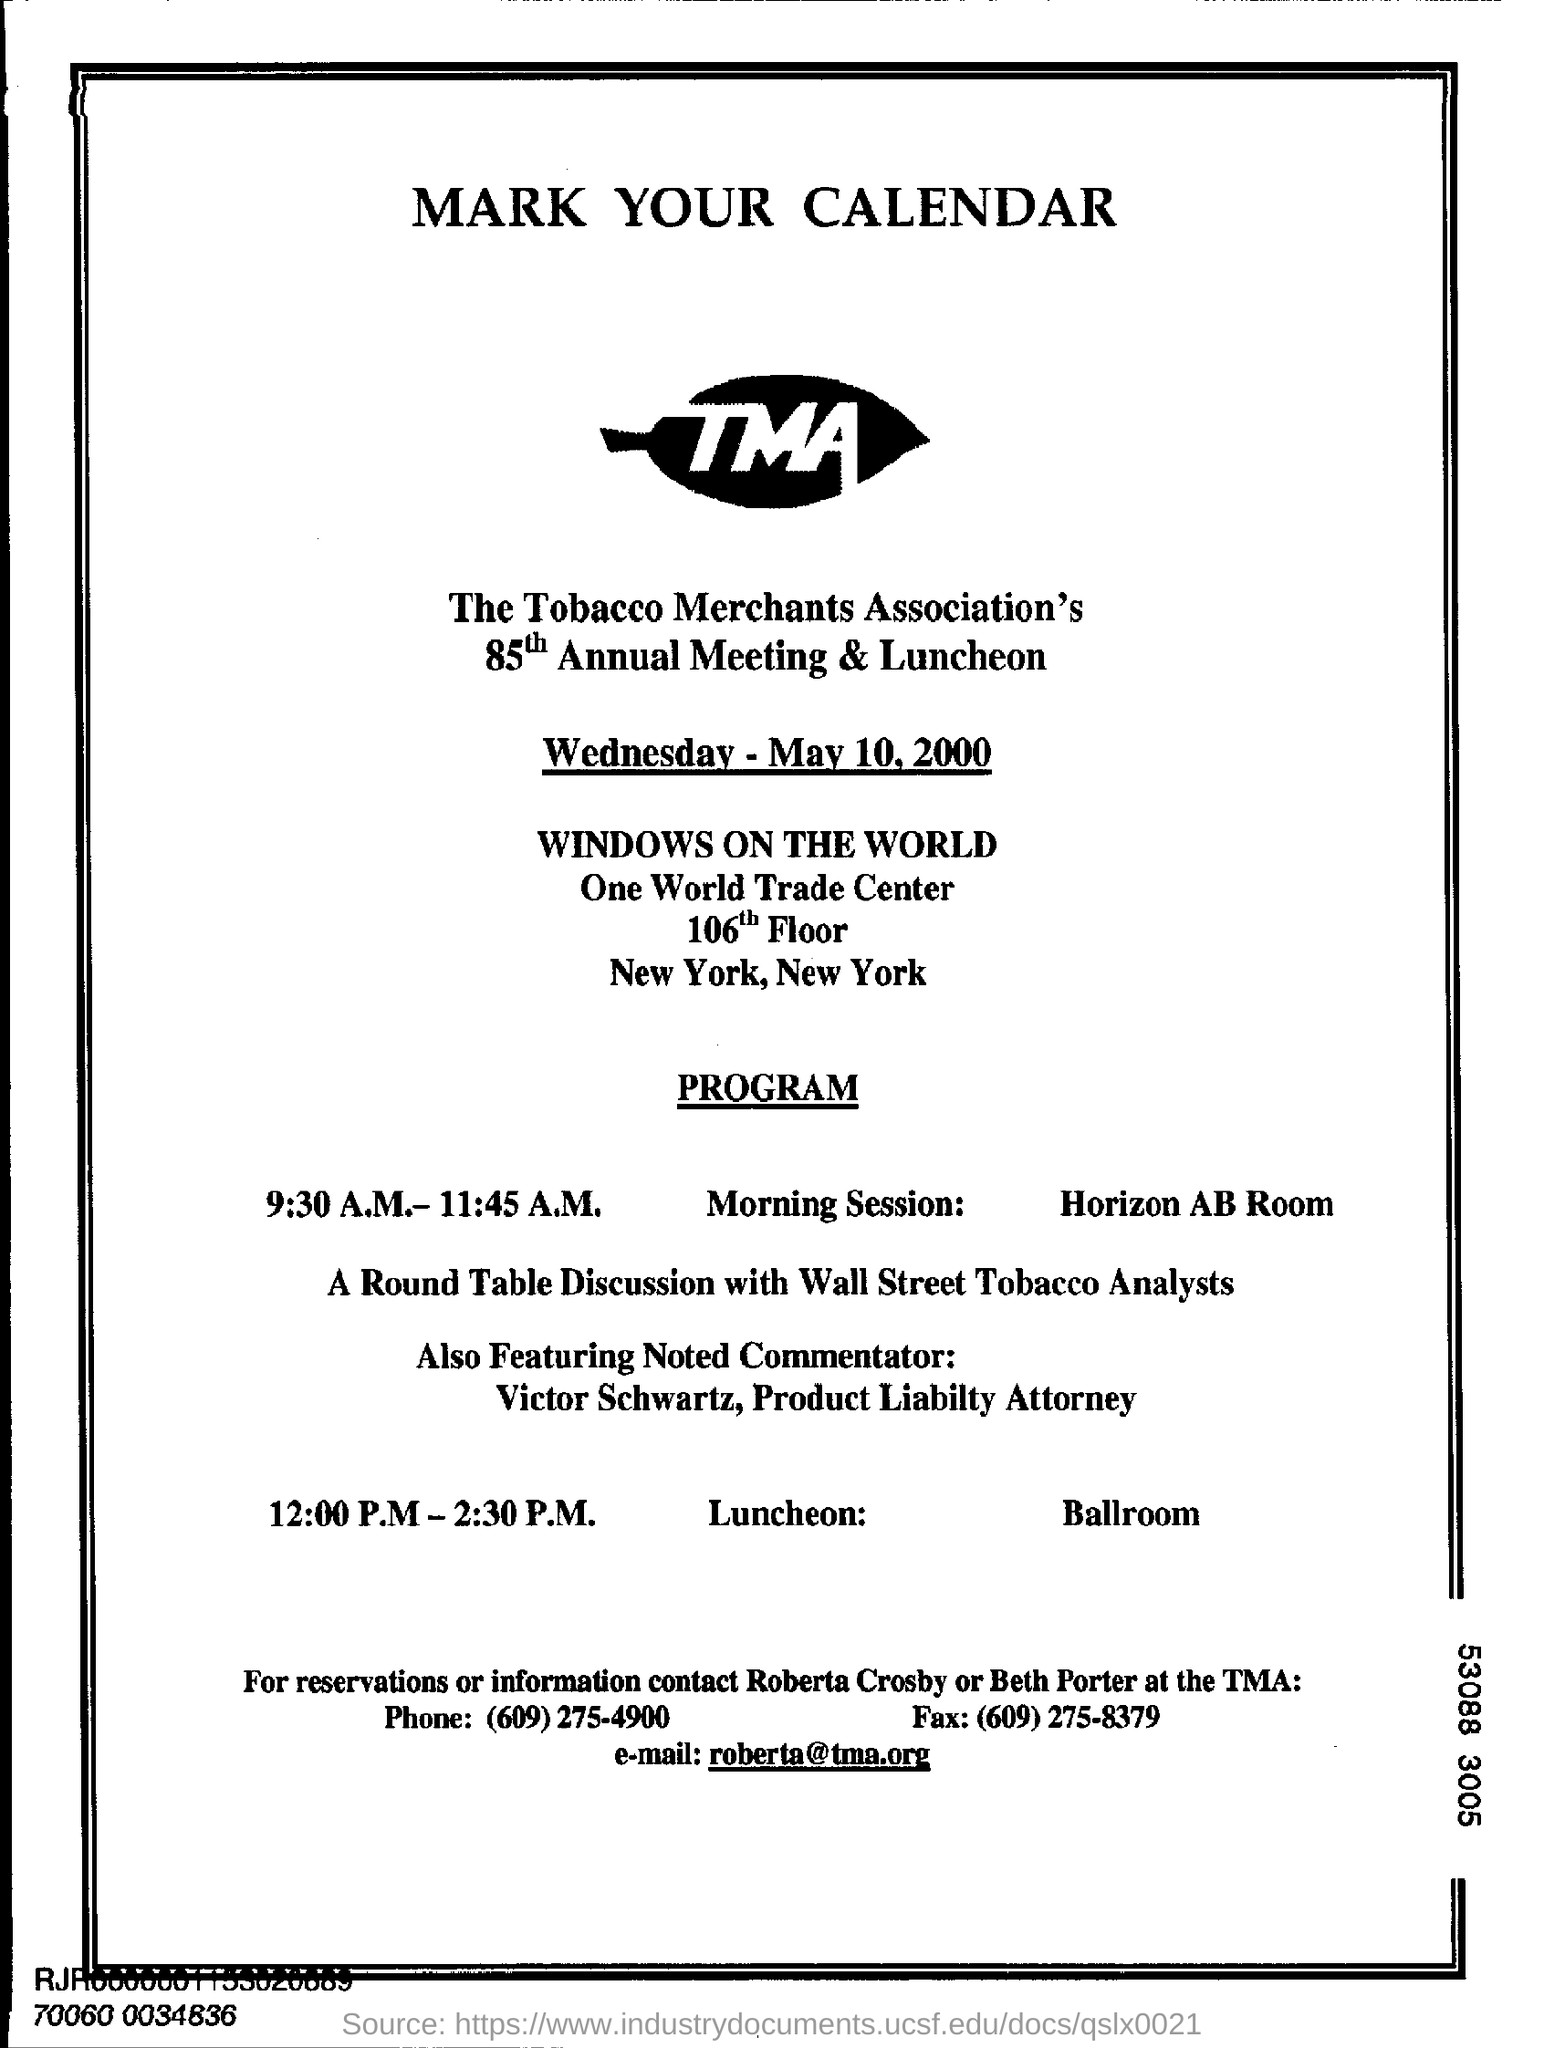Outline some significant characteristics in this image. The full form of (TMA) is "Tobacco Merchants Association. 